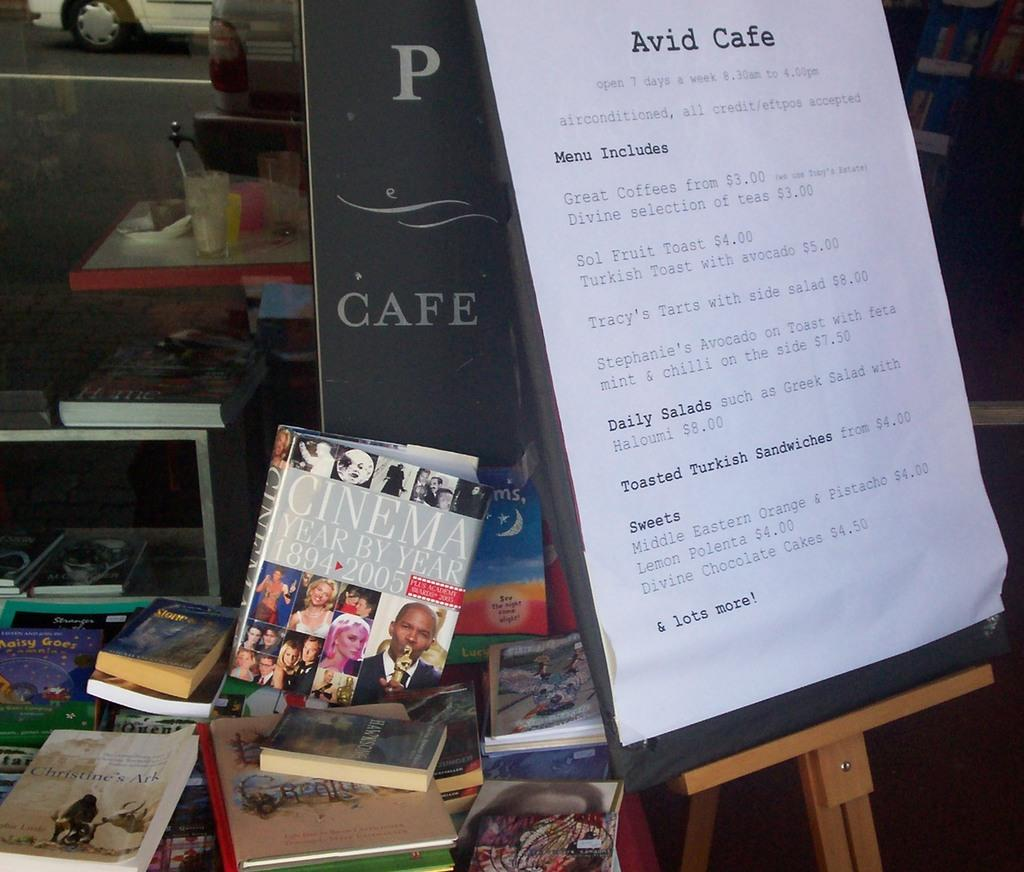<image>
Describe the image concisely. Avid Cafe menu with daily salads and a cinema year by year book. 